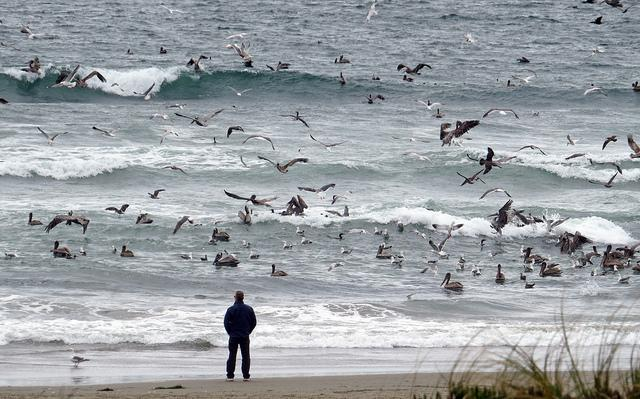What is the most diverse seashore bird?

Choices:
A) sandpiper
B) crow
C) pelican
D) seagull sandpiper 